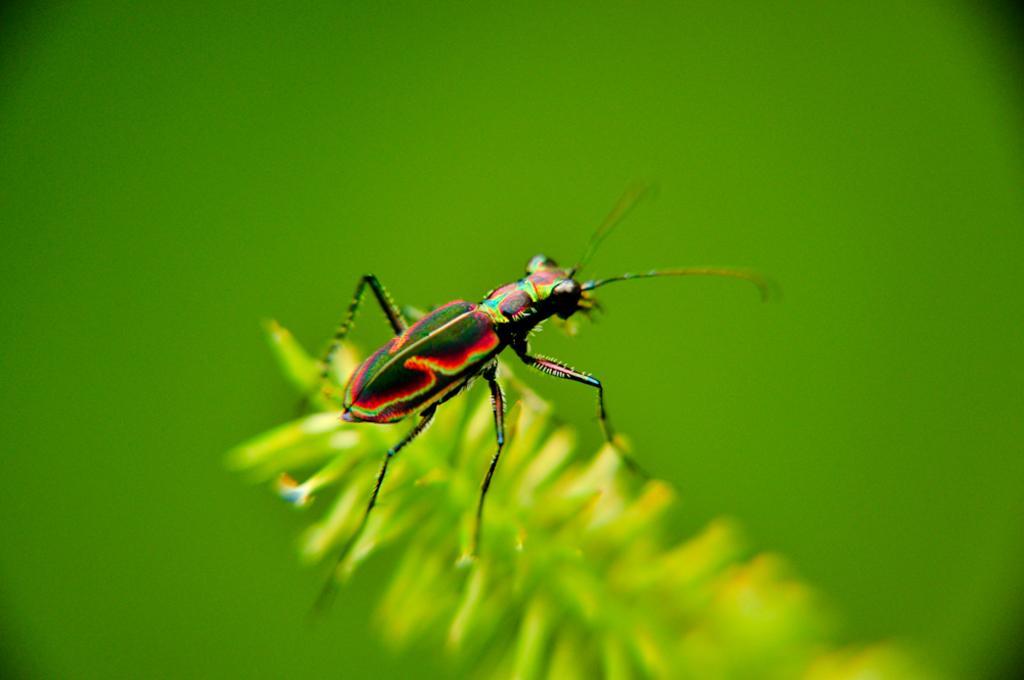Can you describe this image briefly? In this image there is a small insect on the leaves. In the background there is green colour. 